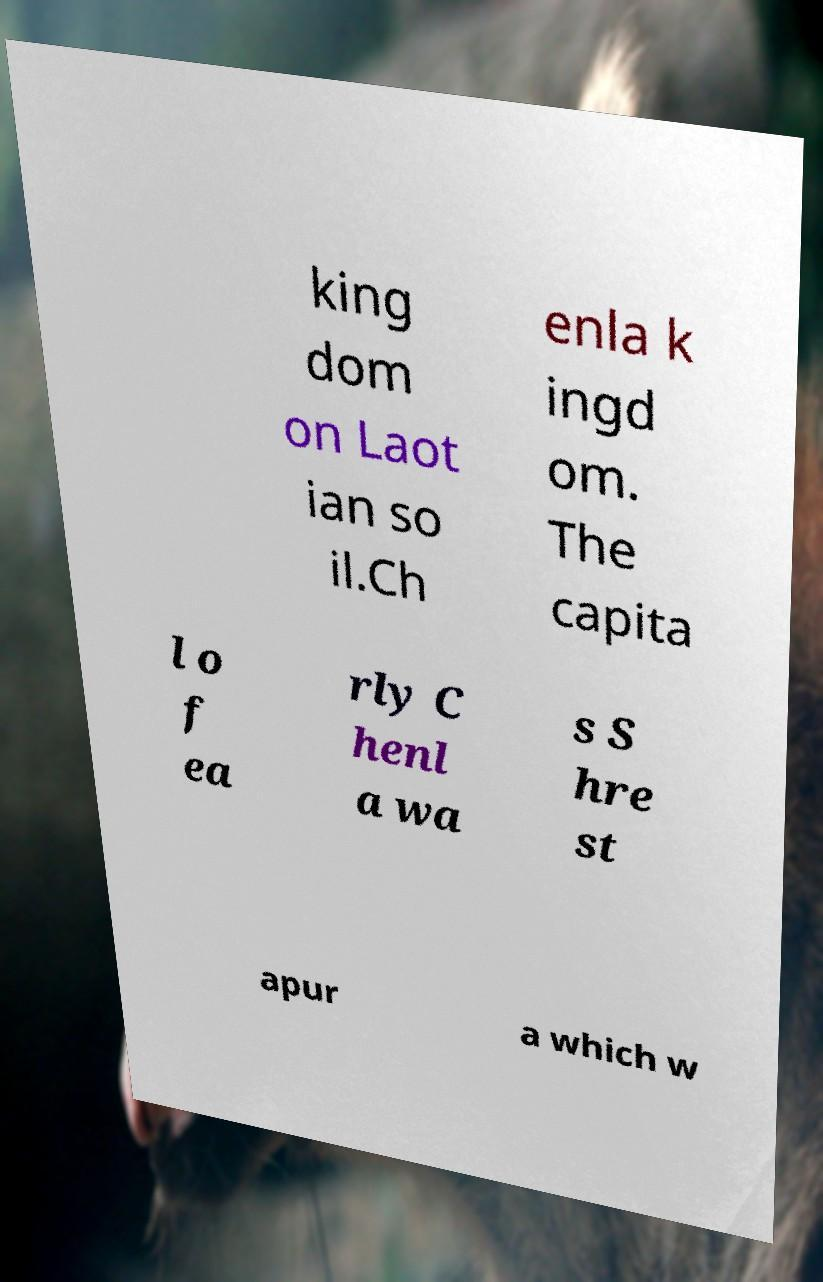There's text embedded in this image that I need extracted. Can you transcribe it verbatim? king dom on Laot ian so il.Ch enla k ingd om. The capita l o f ea rly C henl a wa s S hre st apur a which w 